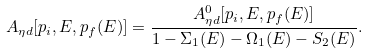Convert formula to latex. <formula><loc_0><loc_0><loc_500><loc_500>A _ { \eta d } [ p _ { i } , E , p _ { f } ( E ) ] = \frac { A ^ { 0 } _ { \eta d } [ p _ { i } , E , p _ { f } ( E ) ] } { 1 - \Sigma _ { 1 } ( E ) - \Omega _ { 1 } ( E ) - S _ { 2 } ( E ) } .</formula> 